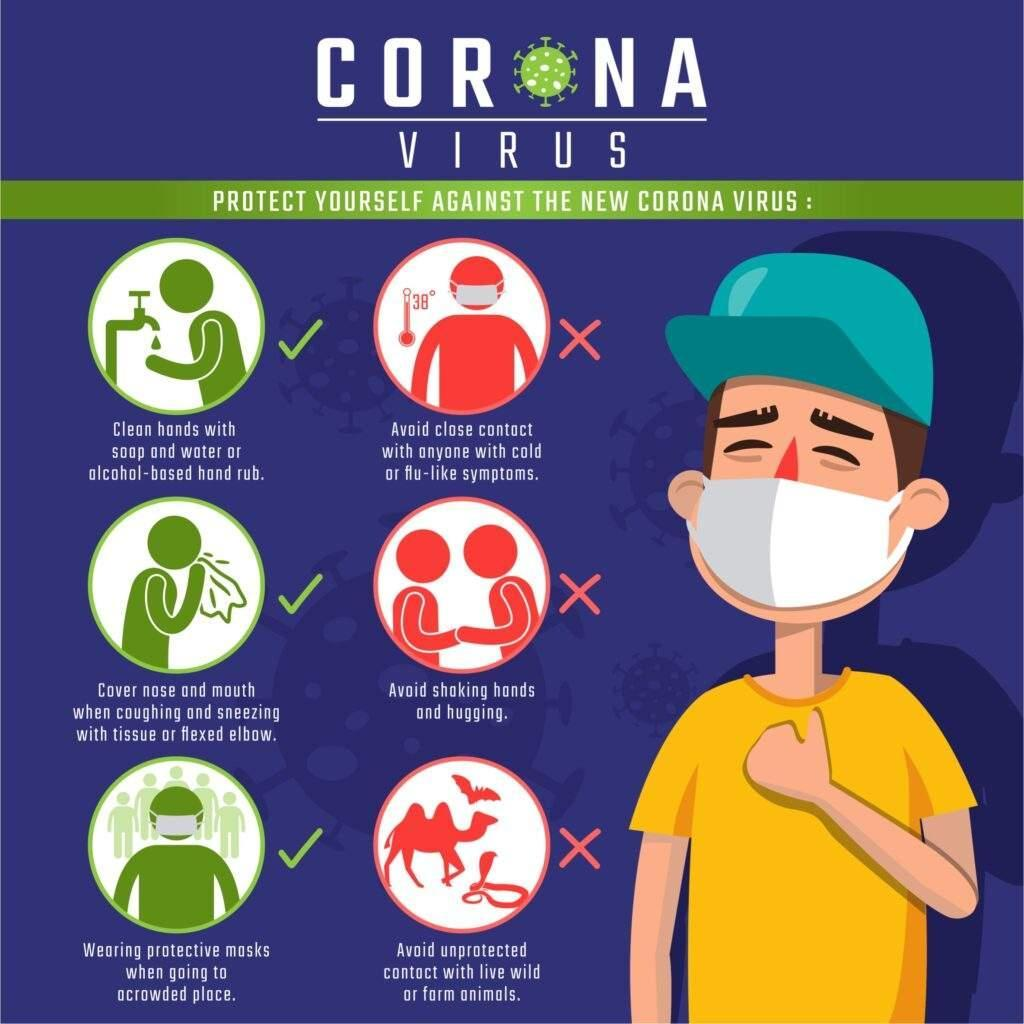How many do's are mentioned in this infographic image?
Answer the question with a short phrase. 3 How many don'ts are shown in this infographic image? 3 